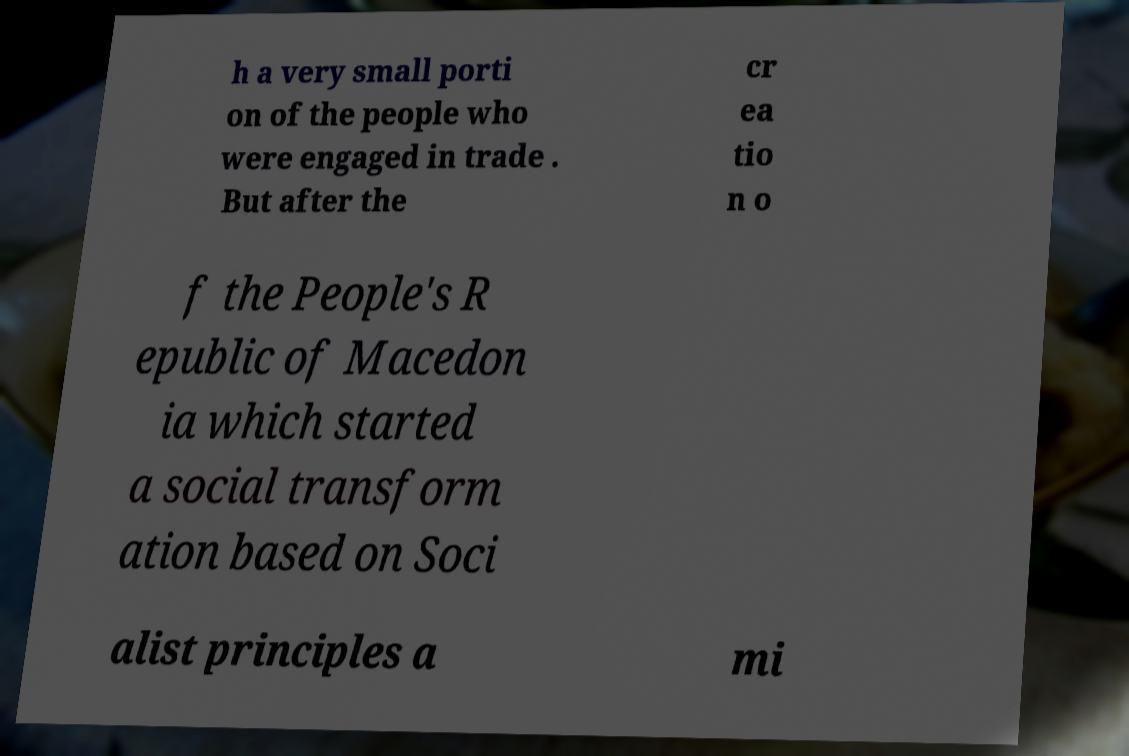Can you accurately transcribe the text from the provided image for me? h a very small porti on of the people who were engaged in trade . But after the cr ea tio n o f the People's R epublic of Macedon ia which started a social transform ation based on Soci alist principles a mi 